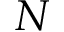<formula> <loc_0><loc_0><loc_500><loc_500>N</formula> 